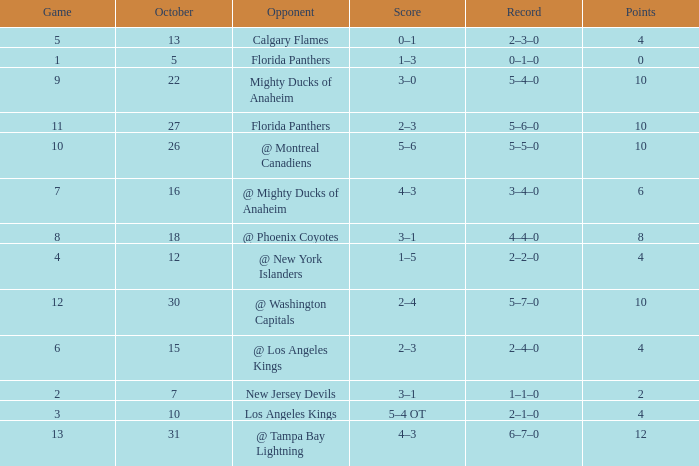What team has a score of 2 3–1. 